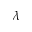Convert formula to latex. <formula><loc_0><loc_0><loc_500><loc_500>\lambda</formula> 